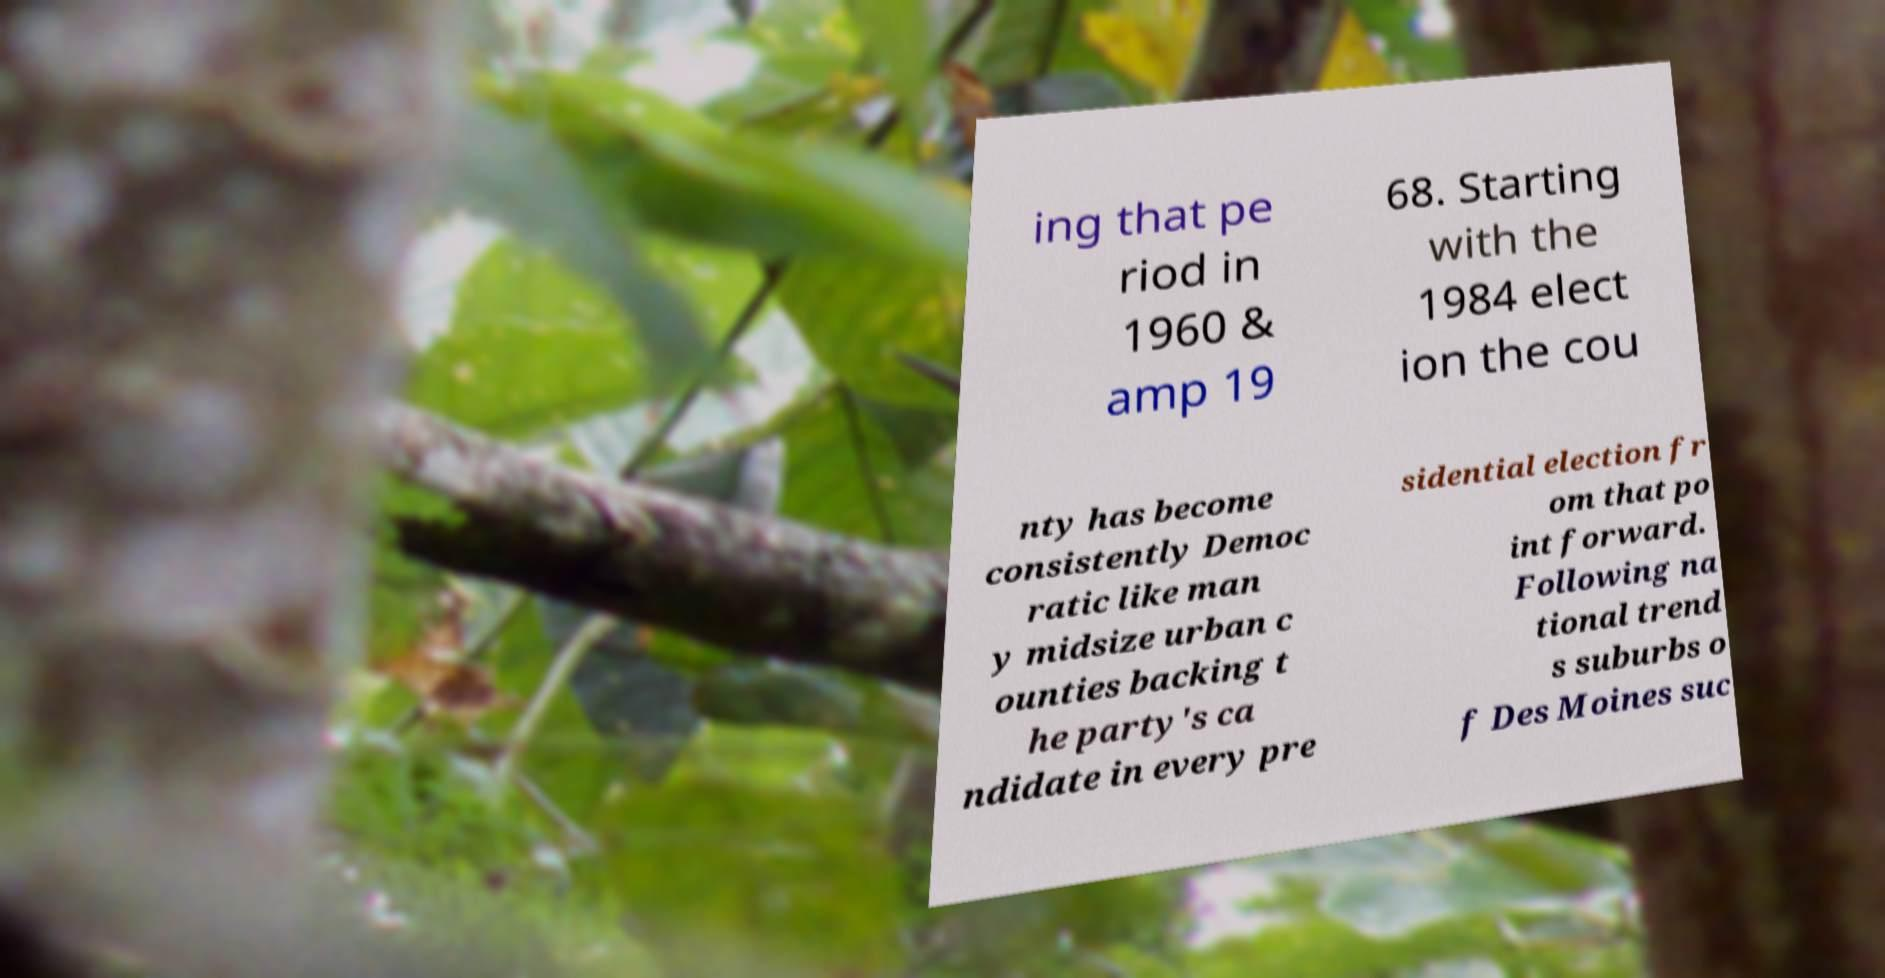Please read and relay the text visible in this image. What does it say? ing that pe riod in 1960 & amp 19 68. Starting with the 1984 elect ion the cou nty has become consistently Democ ratic like man y midsize urban c ounties backing t he party's ca ndidate in every pre sidential election fr om that po int forward. Following na tional trend s suburbs o f Des Moines suc 